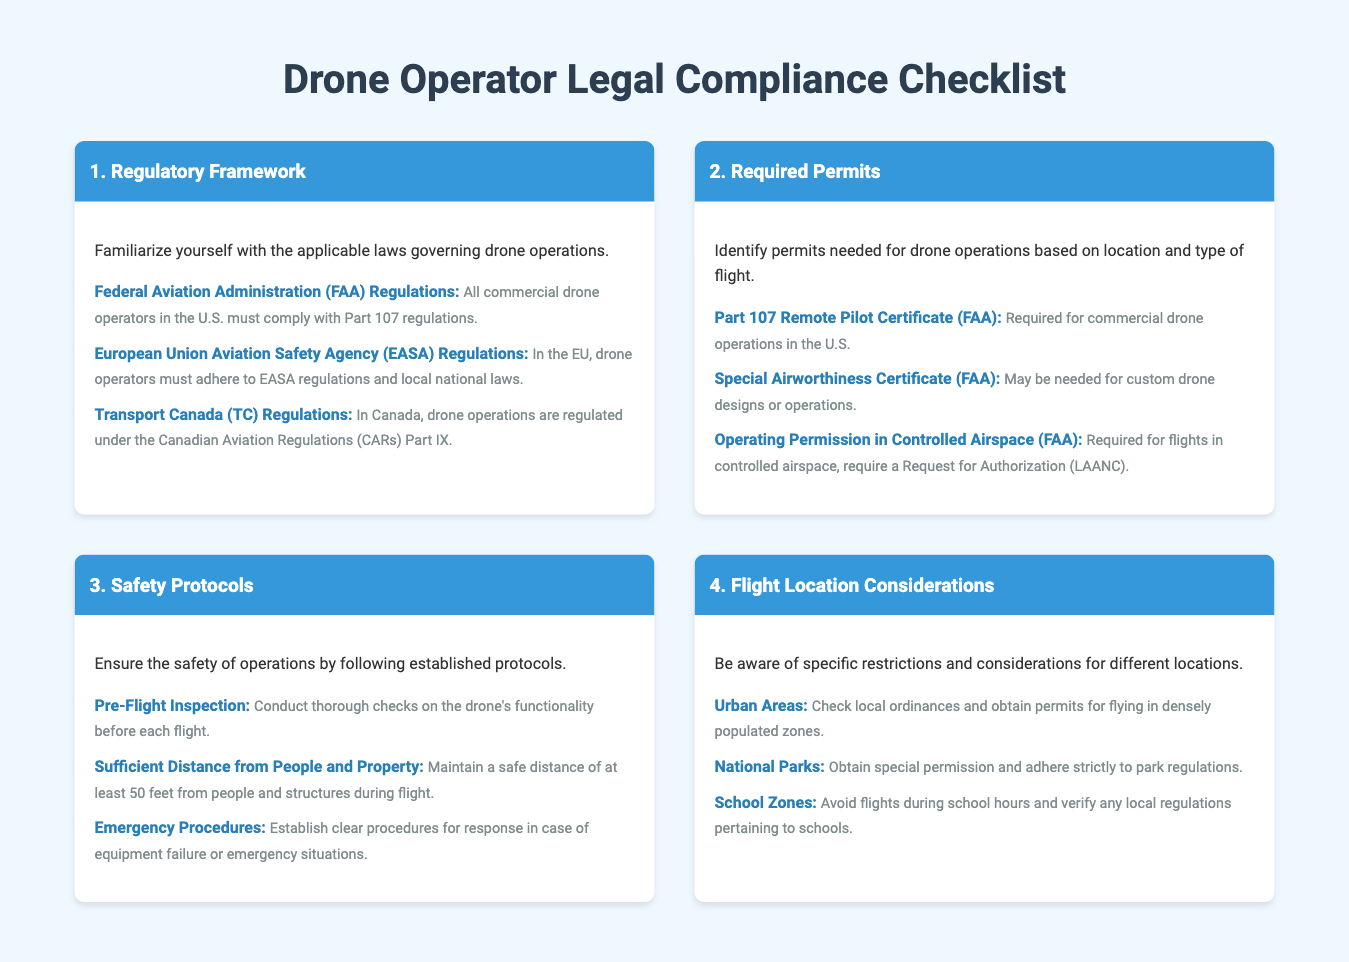What are the FAA regulations for commercial drone operators? The document states that all commercial drone operators in the U.S. must comply with Part 107 regulations.
Answer: Part 107 regulations What is required for commercial drone operations in the U.S.? The document mentions that a Part 107 Remote Pilot Certificate is required for commercial drone operations in the U.S.
Answer: Part 107 Remote Pilot Certificate What is necessary for flights in controlled airspace? According to the document, an Operating Permission in Controlled Airspace is required, which involves a Request for Authorization.
Answer: Request for Authorization How far should a drone maintain distance from people and structures during flight? The document specifies that drones should maintain a safe distance of at least 50 feet from people and structures during flight.
Answer: 50 feet What should be checked before each flight? The document advises that a Pre-Flight Inspection should be conducted to check the drone's functionality before each flight.
Answer: Pre-Flight Inspection What type of areas require local ordinances checks for drone flights? The document indicates that Urban Areas require checks of local ordinances for flying.
Answer: Urban Areas What is required for flying in National Parks? The document states that special permission is required for flying in National Parks.
Answer: Special permission What should be avoided during school hours? The document highlights that flights in School Zones should be avoided during school hours.
Answer: Flights in School Zones 